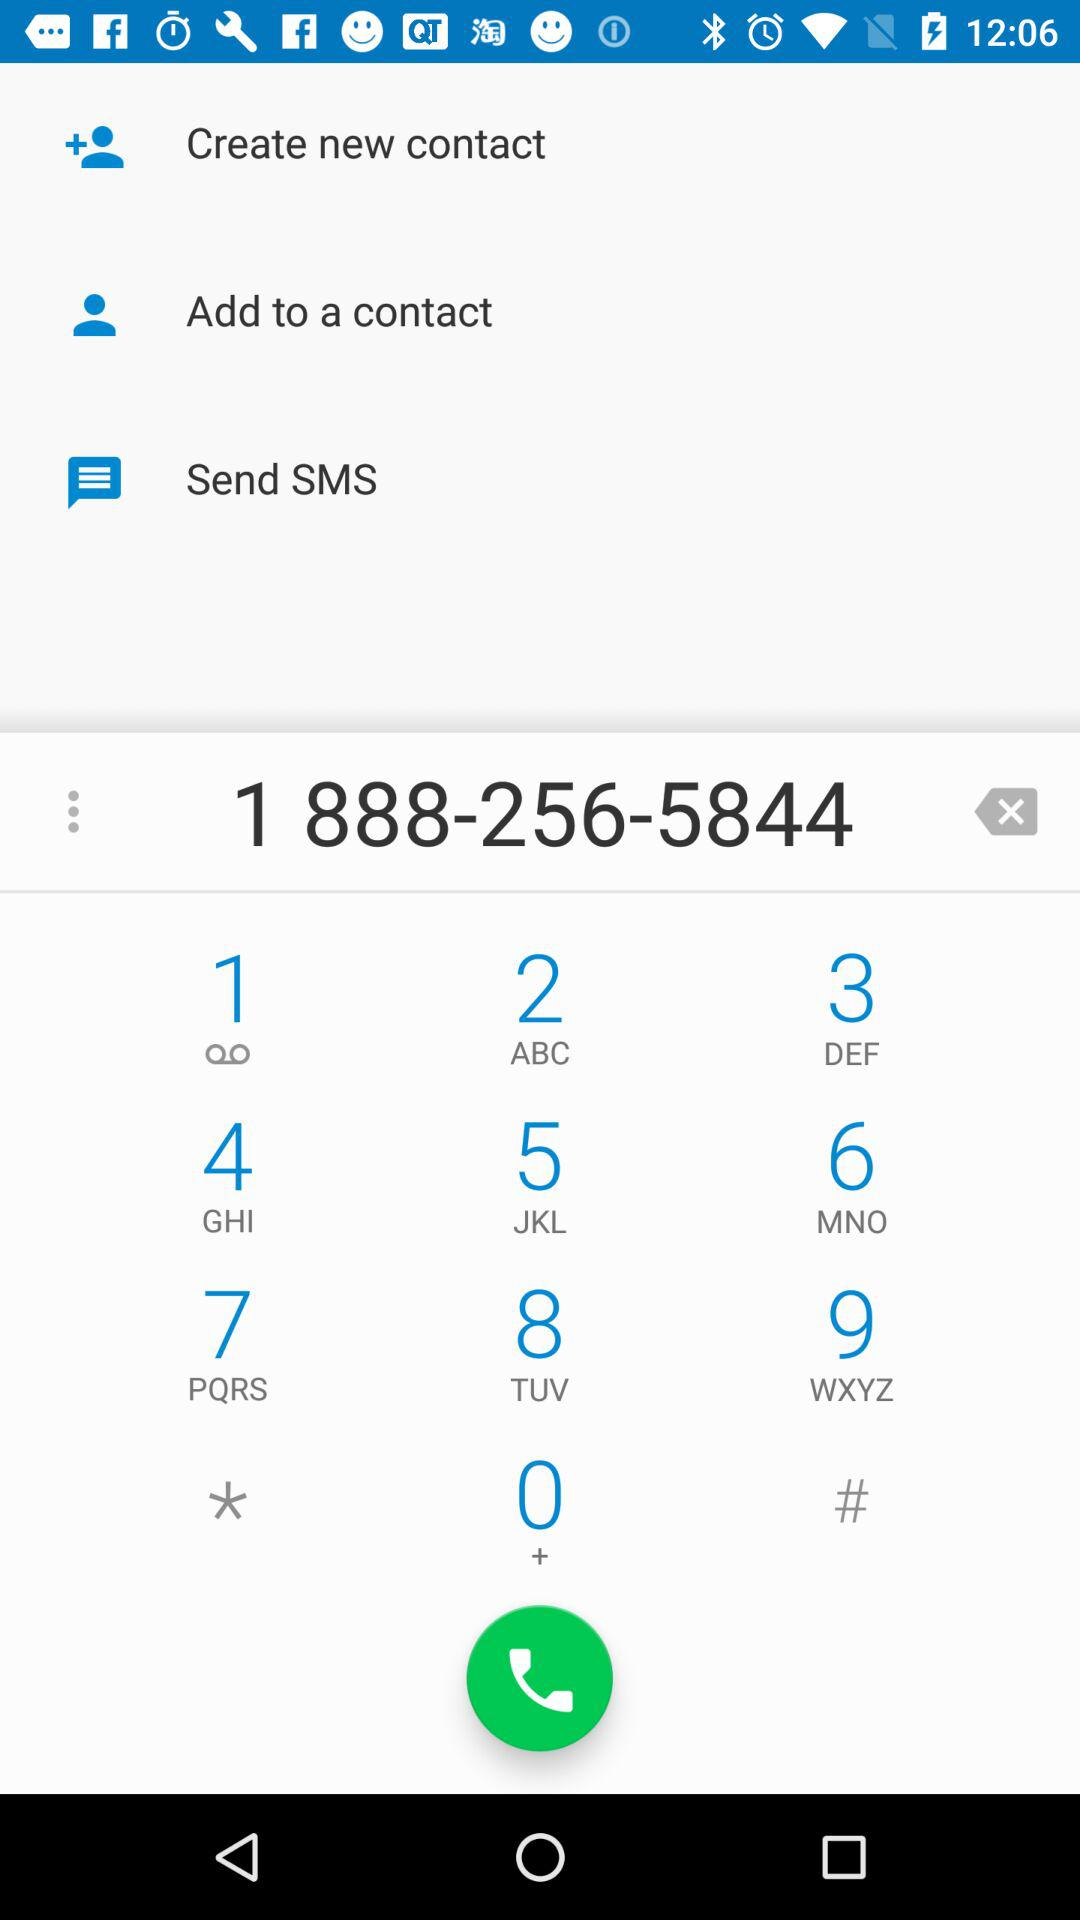What is the number entered for dialing? The number entered for dialing is 1 888-256-5844. 